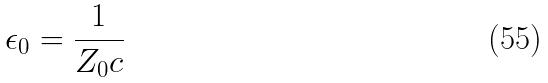<formula> <loc_0><loc_0><loc_500><loc_500>\epsilon _ { 0 } = \frac { 1 } { Z _ { 0 } c }</formula> 